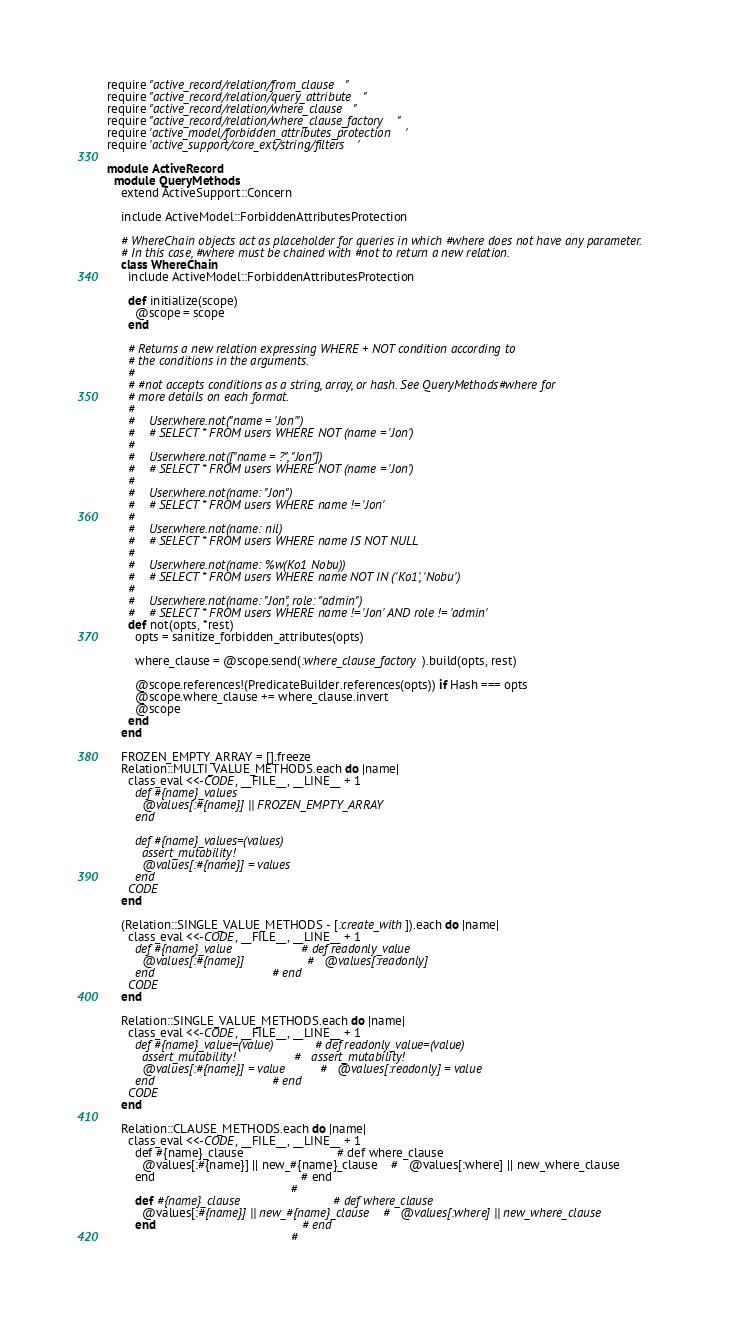<code> <loc_0><loc_0><loc_500><loc_500><_Ruby_>require "active_record/relation/from_clause"
require "active_record/relation/query_attribute"
require "active_record/relation/where_clause"
require "active_record/relation/where_clause_factory"
require 'active_model/forbidden_attributes_protection'
require 'active_support/core_ext/string/filters'

module ActiveRecord
  module QueryMethods
    extend ActiveSupport::Concern

    include ActiveModel::ForbiddenAttributesProtection

    # WhereChain objects act as placeholder for queries in which #where does not have any parameter.
    # In this case, #where must be chained with #not to return a new relation.
    class WhereChain
      include ActiveModel::ForbiddenAttributesProtection

      def initialize(scope)
        @scope = scope
      end

      # Returns a new relation expressing WHERE + NOT condition according to
      # the conditions in the arguments.
      #
      # #not accepts conditions as a string, array, or hash. See QueryMethods#where for
      # more details on each format.
      #
      #    User.where.not("name = 'Jon'")
      #    # SELECT * FROM users WHERE NOT (name = 'Jon')
      #
      #    User.where.not(["name = ?", "Jon"])
      #    # SELECT * FROM users WHERE NOT (name = 'Jon')
      #
      #    User.where.not(name: "Jon")
      #    # SELECT * FROM users WHERE name != 'Jon'
      #
      #    User.where.not(name: nil)
      #    # SELECT * FROM users WHERE name IS NOT NULL
      #
      #    User.where.not(name: %w(Ko1 Nobu))
      #    # SELECT * FROM users WHERE name NOT IN ('Ko1', 'Nobu')
      #
      #    User.where.not(name: "Jon", role: "admin")
      #    # SELECT * FROM users WHERE name != 'Jon' AND role != 'admin'
      def not(opts, *rest)
        opts = sanitize_forbidden_attributes(opts)

        where_clause = @scope.send(:where_clause_factory).build(opts, rest)

        @scope.references!(PredicateBuilder.references(opts)) if Hash === opts
        @scope.where_clause += where_clause.invert
        @scope
      end
    end

    FROZEN_EMPTY_ARRAY = [].freeze
    Relation::MULTI_VALUE_METHODS.each do |name|
      class_eval <<-CODE, __FILE__, __LINE__ + 1
        def #{name}_values
          @values[:#{name}] || FROZEN_EMPTY_ARRAY
        end

        def #{name}_values=(values)
          assert_mutability!
          @values[:#{name}] = values
        end
      CODE
    end

    (Relation::SINGLE_VALUE_METHODS - [:create_with]).each do |name|
      class_eval <<-CODE, __FILE__, __LINE__ + 1
        def #{name}_value                    # def readonly_value
          @values[:#{name}]                  #   @values[:readonly]
        end                                  # end
      CODE
    end

    Relation::SINGLE_VALUE_METHODS.each do |name|
      class_eval <<-CODE, __FILE__, __LINE__ + 1
        def #{name}_value=(value)            # def readonly_value=(value)
          assert_mutability!                 #   assert_mutability!
          @values[:#{name}] = value          #   @values[:readonly] = value
        end                                  # end
      CODE
    end

    Relation::CLAUSE_METHODS.each do |name|
      class_eval <<-CODE, __FILE__, __LINE__ + 1
        def #{name}_clause                           # def where_clause
          @values[:#{name}] || new_#{name}_clause    #   @values[:where] || new_where_clause
        end                                          # end
                                                     #</code> 